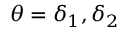<formula> <loc_0><loc_0><loc_500><loc_500>\theta = \delta _ { 1 } , \delta _ { 2 }</formula> 